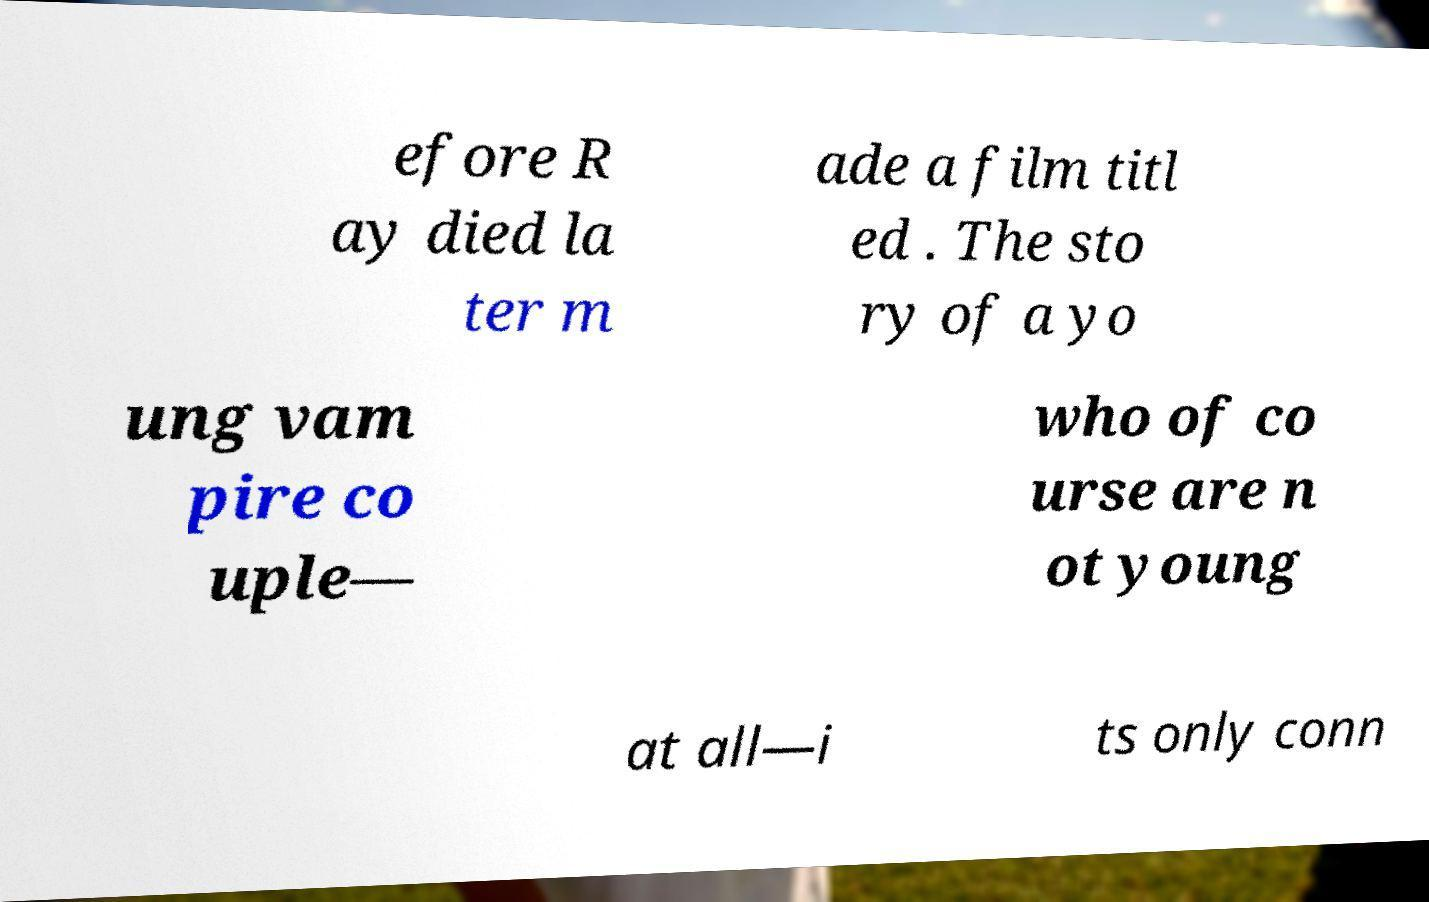There's text embedded in this image that I need extracted. Can you transcribe it verbatim? efore R ay died la ter m ade a film titl ed . The sto ry of a yo ung vam pire co uple— who of co urse are n ot young at all—i ts only conn 